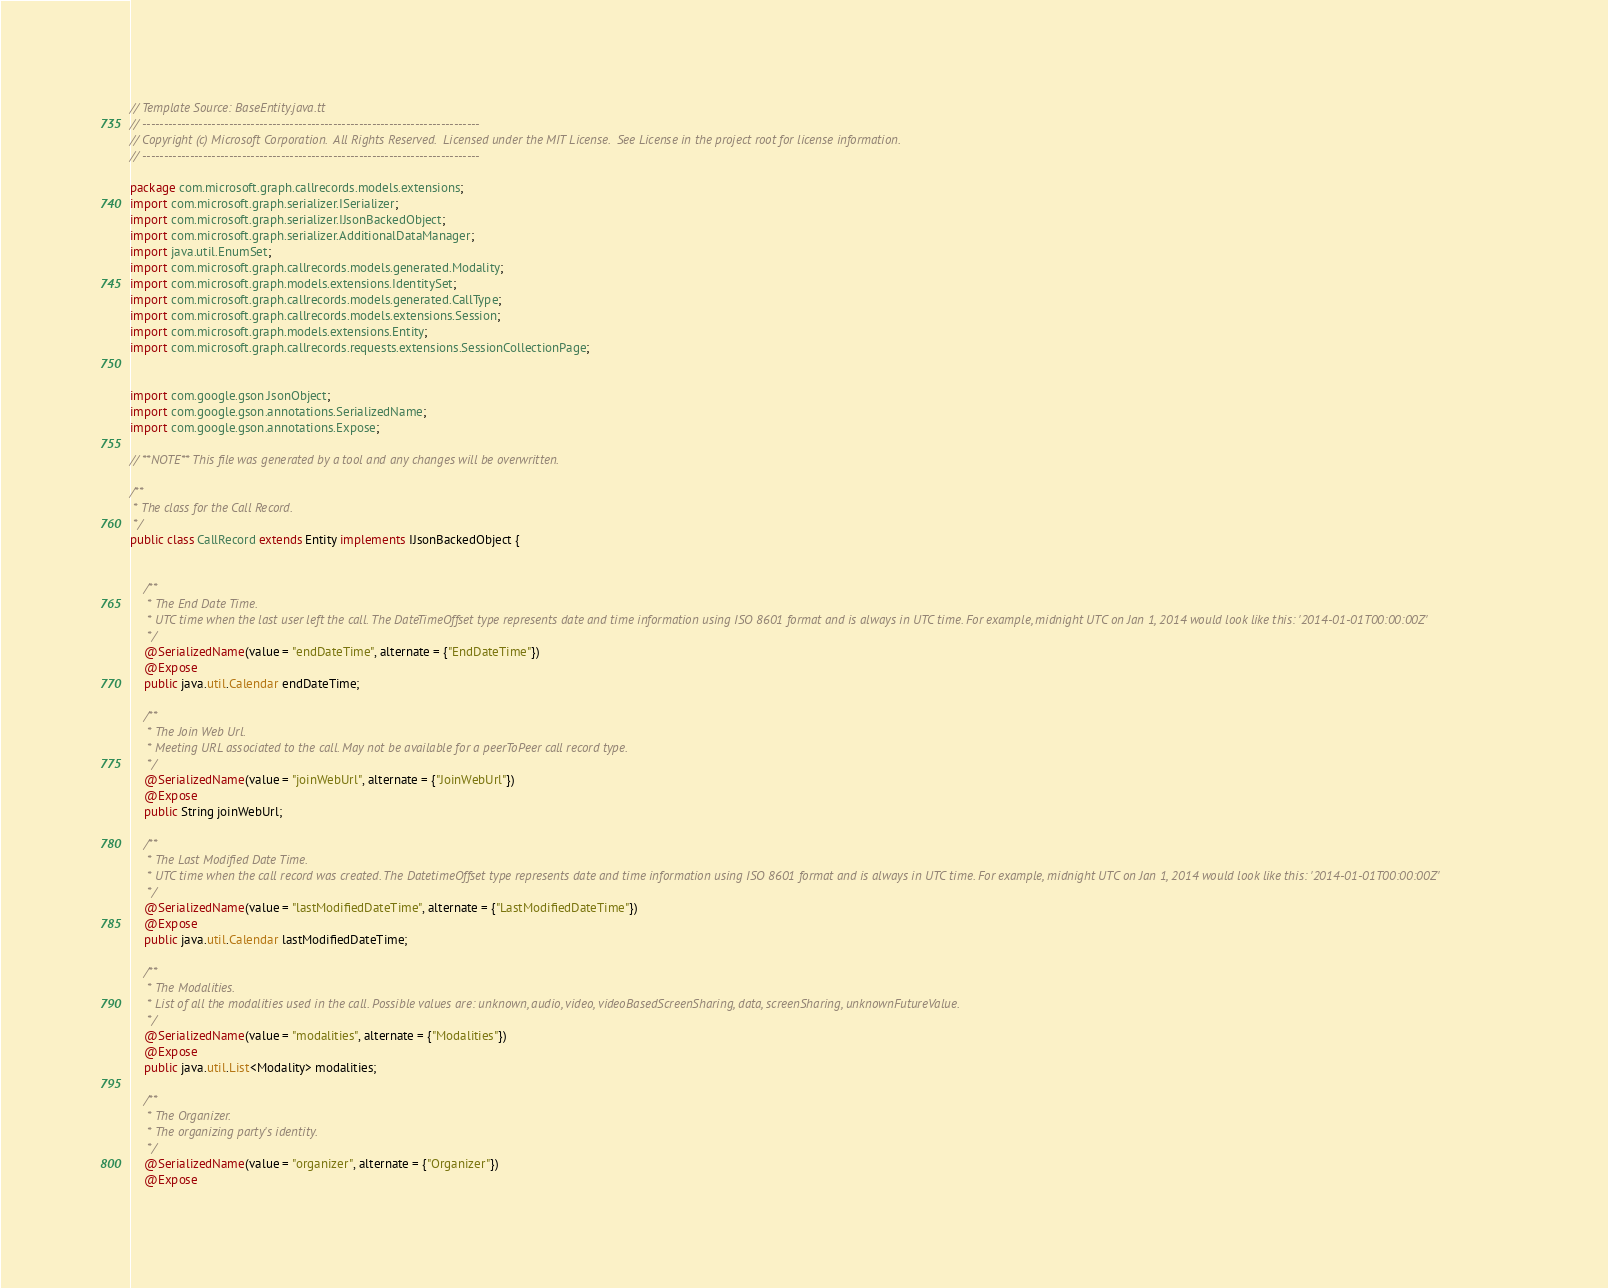Convert code to text. <code><loc_0><loc_0><loc_500><loc_500><_Java_>// Template Source: BaseEntity.java.tt
// ------------------------------------------------------------------------------
// Copyright (c) Microsoft Corporation.  All Rights Reserved.  Licensed under the MIT License.  See License in the project root for license information.
// ------------------------------------------------------------------------------

package com.microsoft.graph.callrecords.models.extensions;
import com.microsoft.graph.serializer.ISerializer;
import com.microsoft.graph.serializer.IJsonBackedObject;
import com.microsoft.graph.serializer.AdditionalDataManager;
import java.util.EnumSet;
import com.microsoft.graph.callrecords.models.generated.Modality;
import com.microsoft.graph.models.extensions.IdentitySet;
import com.microsoft.graph.callrecords.models.generated.CallType;
import com.microsoft.graph.callrecords.models.extensions.Session;
import com.microsoft.graph.models.extensions.Entity;
import com.microsoft.graph.callrecords.requests.extensions.SessionCollectionPage;


import com.google.gson.JsonObject;
import com.google.gson.annotations.SerializedName;
import com.google.gson.annotations.Expose;

// **NOTE** This file was generated by a tool and any changes will be overwritten.

/**
 * The class for the Call Record.
 */
public class CallRecord extends Entity implements IJsonBackedObject {


    /**
     * The End Date Time.
     * UTC time when the last user left the call. The DateTimeOffset type represents date and time information using ISO 8601 format and is always in UTC time. For example, midnight UTC on Jan 1, 2014 would look like this: '2014-01-01T00:00:00Z'
     */
    @SerializedName(value = "endDateTime", alternate = {"EndDateTime"})
    @Expose
    public java.util.Calendar endDateTime;

    /**
     * The Join Web Url.
     * Meeting URL associated to the call. May not be available for a peerToPeer call record type.
     */
    @SerializedName(value = "joinWebUrl", alternate = {"JoinWebUrl"})
    @Expose
    public String joinWebUrl;

    /**
     * The Last Modified Date Time.
     * UTC time when the call record was created. The DatetimeOffset type represents date and time information using ISO 8601 format and is always in UTC time. For example, midnight UTC on Jan 1, 2014 would look like this: '2014-01-01T00:00:00Z'
     */
    @SerializedName(value = "lastModifiedDateTime", alternate = {"LastModifiedDateTime"})
    @Expose
    public java.util.Calendar lastModifiedDateTime;

    /**
     * The Modalities.
     * List of all the modalities used in the call. Possible values are: unknown, audio, video, videoBasedScreenSharing, data, screenSharing, unknownFutureValue.
     */
    @SerializedName(value = "modalities", alternate = {"Modalities"})
    @Expose
    public java.util.List<Modality> modalities;

    /**
     * The Organizer.
     * The organizing party's identity.
     */
    @SerializedName(value = "organizer", alternate = {"Organizer"})
    @Expose</code> 